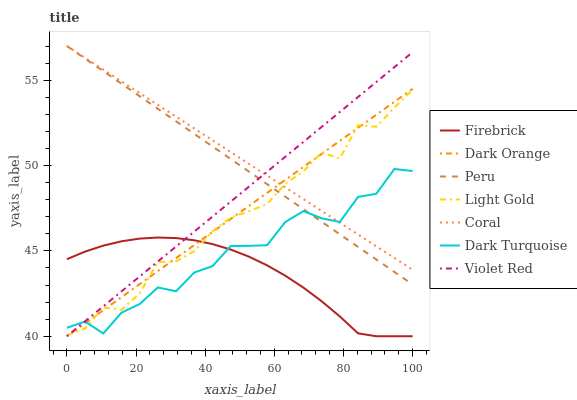Does Firebrick have the minimum area under the curve?
Answer yes or no. Yes. Does Coral have the maximum area under the curve?
Answer yes or no. Yes. Does Violet Red have the minimum area under the curve?
Answer yes or no. No. Does Violet Red have the maximum area under the curve?
Answer yes or no. No. Is Violet Red the smoothest?
Answer yes or no. Yes. Is Dark Turquoise the roughest?
Answer yes or no. Yes. Is Dark Turquoise the smoothest?
Answer yes or no. No. Is Violet Red the roughest?
Answer yes or no. No. Does Dark Turquoise have the lowest value?
Answer yes or no. No. Does Coral have the highest value?
Answer yes or no. Yes. Does Violet Red have the highest value?
Answer yes or no. No. Is Firebrick less than Coral?
Answer yes or no. Yes. Is Peru greater than Firebrick?
Answer yes or no. Yes. Does Coral intersect Light Gold?
Answer yes or no. Yes. Is Coral less than Light Gold?
Answer yes or no. No. Is Coral greater than Light Gold?
Answer yes or no. No. Does Firebrick intersect Coral?
Answer yes or no. No. 